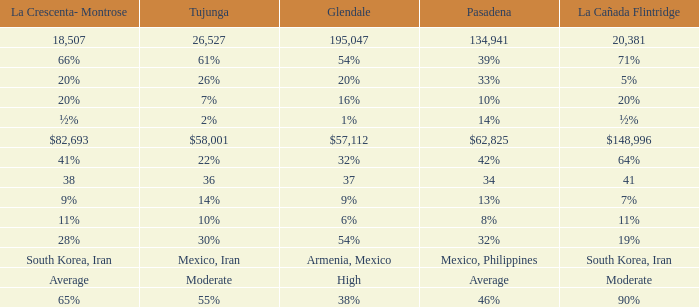What is the percentage of La Canada Flintridge when Tujunga is 7%? 20%. Could you parse the entire table as a dict? {'header': ['La Crescenta- Montrose', 'Tujunga', 'Glendale', 'Pasadena', 'La Cañada Flintridge'], 'rows': [['18,507', '26,527', '195,047', '134,941', '20,381'], ['66%', '61%', '54%', '39%', '71%'], ['20%', '26%', '20%', '33%', '5%'], ['20%', '7%', '16%', '10%', '20%'], ['½%', '2%', '1%', '14%', '½%'], ['$82,693', '$58,001', '$57,112', '$62,825', '$148,996'], ['41%', '22%', '32%', '42%', '64%'], ['38', '36', '37', '34', '41'], ['9%', '14%', '9%', '13%', '7%'], ['11%', '10%', '6%', '8%', '11%'], ['28%', '30%', '54%', '32%', '19%'], ['South Korea, Iran', 'Mexico, Iran', 'Armenia, Mexico', 'Mexico, Philippines', 'South Korea, Iran'], ['Average', 'Moderate', 'High', 'Average', 'Moderate'], ['65%', '55%', '38%', '46%', '90%']]} 